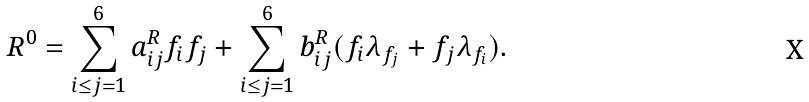Convert formula to latex. <formula><loc_0><loc_0><loc_500><loc_500>R ^ { 0 } = \sum _ { i \leq j = 1 } ^ { 6 } a _ { i j } ^ { R } f _ { i } f _ { j } + \sum _ { i \leq j = 1 } ^ { 6 } b _ { i j } ^ { R } ( f _ { i } \lambda _ { f _ { j } } + f _ { j } \lambda _ { f _ { i } } ) .</formula> 